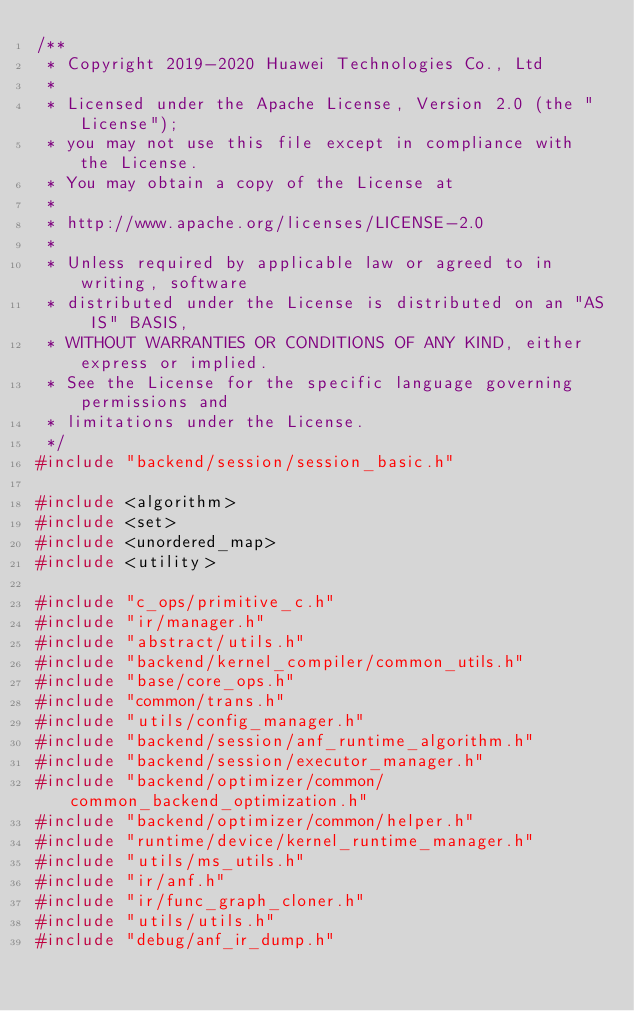Convert code to text. <code><loc_0><loc_0><loc_500><loc_500><_C++_>/**
 * Copyright 2019-2020 Huawei Technologies Co., Ltd
 *
 * Licensed under the Apache License, Version 2.0 (the "License");
 * you may not use this file except in compliance with the License.
 * You may obtain a copy of the License at
 *
 * http://www.apache.org/licenses/LICENSE-2.0
 *
 * Unless required by applicable law or agreed to in writing, software
 * distributed under the License is distributed on an "AS IS" BASIS,
 * WITHOUT WARRANTIES OR CONDITIONS OF ANY KIND, either express or implied.
 * See the License for the specific language governing permissions and
 * limitations under the License.
 */
#include "backend/session/session_basic.h"

#include <algorithm>
#include <set>
#include <unordered_map>
#include <utility>

#include "c_ops/primitive_c.h"
#include "ir/manager.h"
#include "abstract/utils.h"
#include "backend/kernel_compiler/common_utils.h"
#include "base/core_ops.h"
#include "common/trans.h"
#include "utils/config_manager.h"
#include "backend/session/anf_runtime_algorithm.h"
#include "backend/session/executor_manager.h"
#include "backend/optimizer/common/common_backend_optimization.h"
#include "backend/optimizer/common/helper.h"
#include "runtime/device/kernel_runtime_manager.h"
#include "utils/ms_utils.h"
#include "ir/anf.h"
#include "ir/func_graph_cloner.h"
#include "utils/utils.h"
#include "debug/anf_ir_dump.h"</code> 